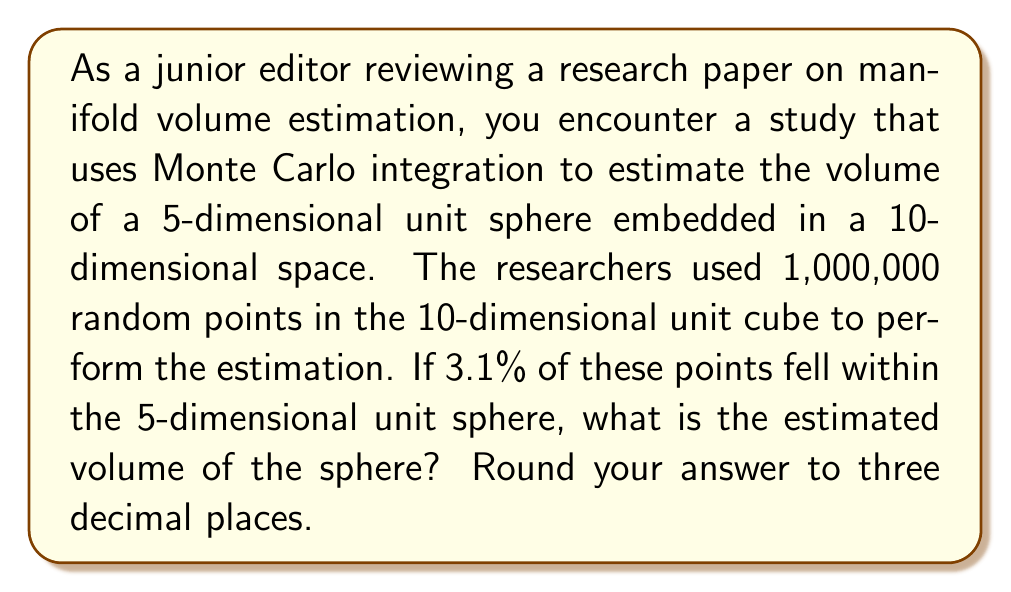What is the answer to this math problem? To solve this problem, we need to understand the principles of Monte Carlo integration for estimating volumes of high-dimensional manifolds. Here's a step-by-step explanation:

1) Monte Carlo integration for volume estimation works by comparing the volume of a known shape (in this case, the 10-dimensional unit cube) to the volume of the shape we want to estimate (the 5-dimensional unit sphere embedded in 10-dimensional space).

2) The volume of a 10-dimensional unit cube is 1, as each side has length 1.

3) The ratio of points falling within the sphere to the total number of points is an estimate of the ratio of the sphere's volume to the cube's volume.

4) Let $V_s$ be the volume of the sphere. Then:

   $$\frac{V_s}{1} \approx \frac{\text{Points in sphere}}{\text{Total points}}$$

5) We're given that 3.1% of the points fell within the sphere, which is 0.031 in decimal form.

6) Substituting the values:

   $$\frac{V_s}{1} \approx \frac{0.031}{1} = 0.031$$

7) Therefore, $V_s \approx 0.031$

8) Rounding to three decimal places gives 0.031.

This method provides an estimate of the volume. The accuracy improves with more random points, but there will always be some statistical uncertainty.
Answer: The estimated volume of the 5-dimensional unit sphere is approximately 0.031. 